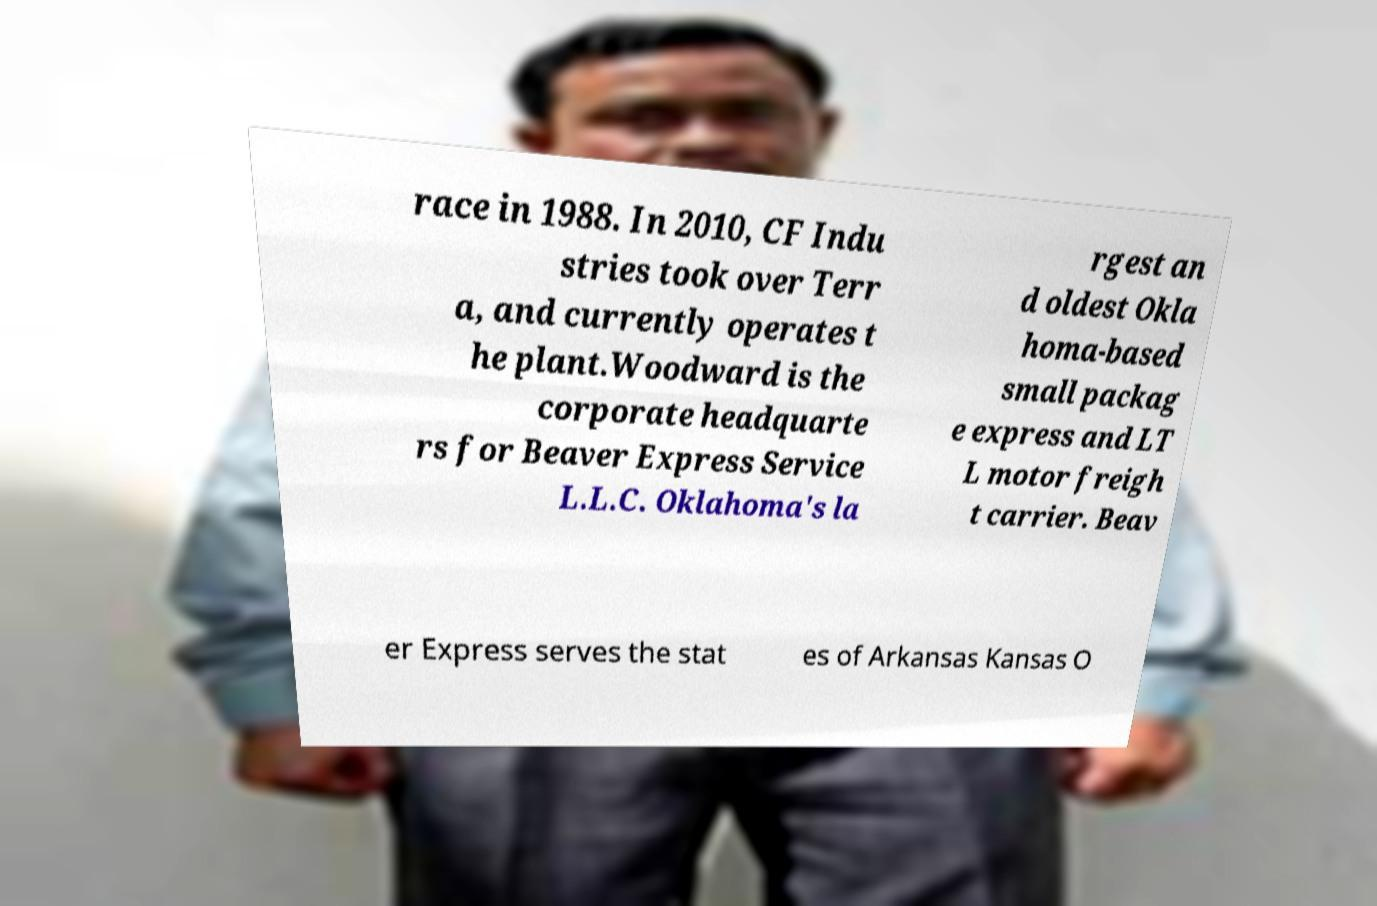Please read and relay the text visible in this image. What does it say? race in 1988. In 2010, CF Indu stries took over Terr a, and currently operates t he plant.Woodward is the corporate headquarte rs for Beaver Express Service L.L.C. Oklahoma's la rgest an d oldest Okla homa-based small packag e express and LT L motor freigh t carrier. Beav er Express serves the stat es of Arkansas Kansas O 